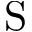Convert formula to latex. <formula><loc_0><loc_0><loc_500><loc_500>S</formula> 